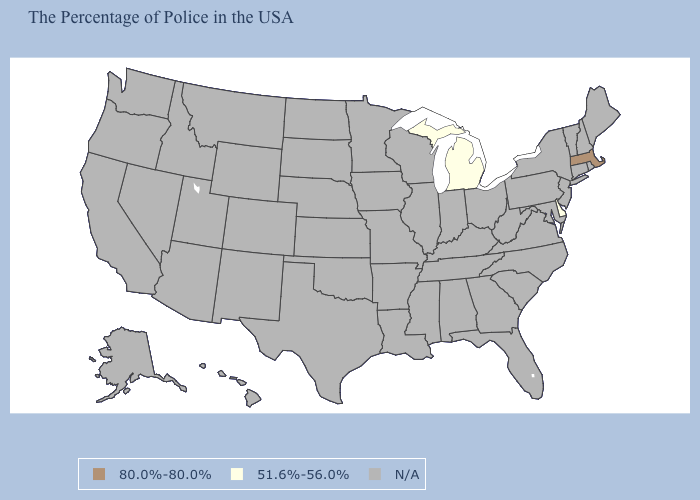Does Massachusetts have the highest value in the USA?
Quick response, please. Yes. Is the legend a continuous bar?
Write a very short answer. No. What is the value of Tennessee?
Give a very brief answer. N/A. Name the states that have a value in the range N/A?
Give a very brief answer. Maine, Rhode Island, New Hampshire, Vermont, Connecticut, New York, New Jersey, Maryland, Pennsylvania, Virginia, North Carolina, South Carolina, West Virginia, Ohio, Florida, Georgia, Kentucky, Indiana, Alabama, Tennessee, Wisconsin, Illinois, Mississippi, Louisiana, Missouri, Arkansas, Minnesota, Iowa, Kansas, Nebraska, Oklahoma, Texas, South Dakota, North Dakota, Wyoming, Colorado, New Mexico, Utah, Montana, Arizona, Idaho, Nevada, California, Washington, Oregon, Alaska, Hawaii. Name the states that have a value in the range 80.0%-80.0%?
Write a very short answer. Massachusetts. What is the value of Ohio?
Short answer required. N/A. What is the value of Illinois?
Give a very brief answer. N/A. What is the value of Utah?
Be succinct. N/A. How many symbols are there in the legend?
Quick response, please. 3. What is the value of Rhode Island?
Answer briefly. N/A. What is the lowest value in the USA?
Keep it brief. 51.6%-56.0%. 